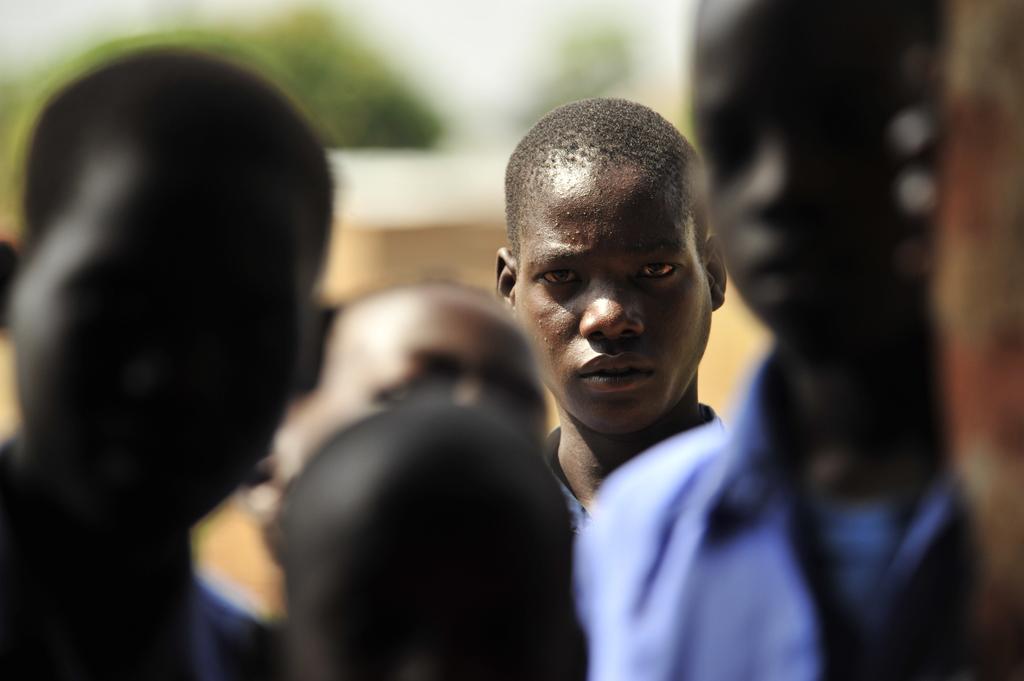Could you give a brief overview of what you see in this image? In the center of the image there are people. The background of the image is blur. 